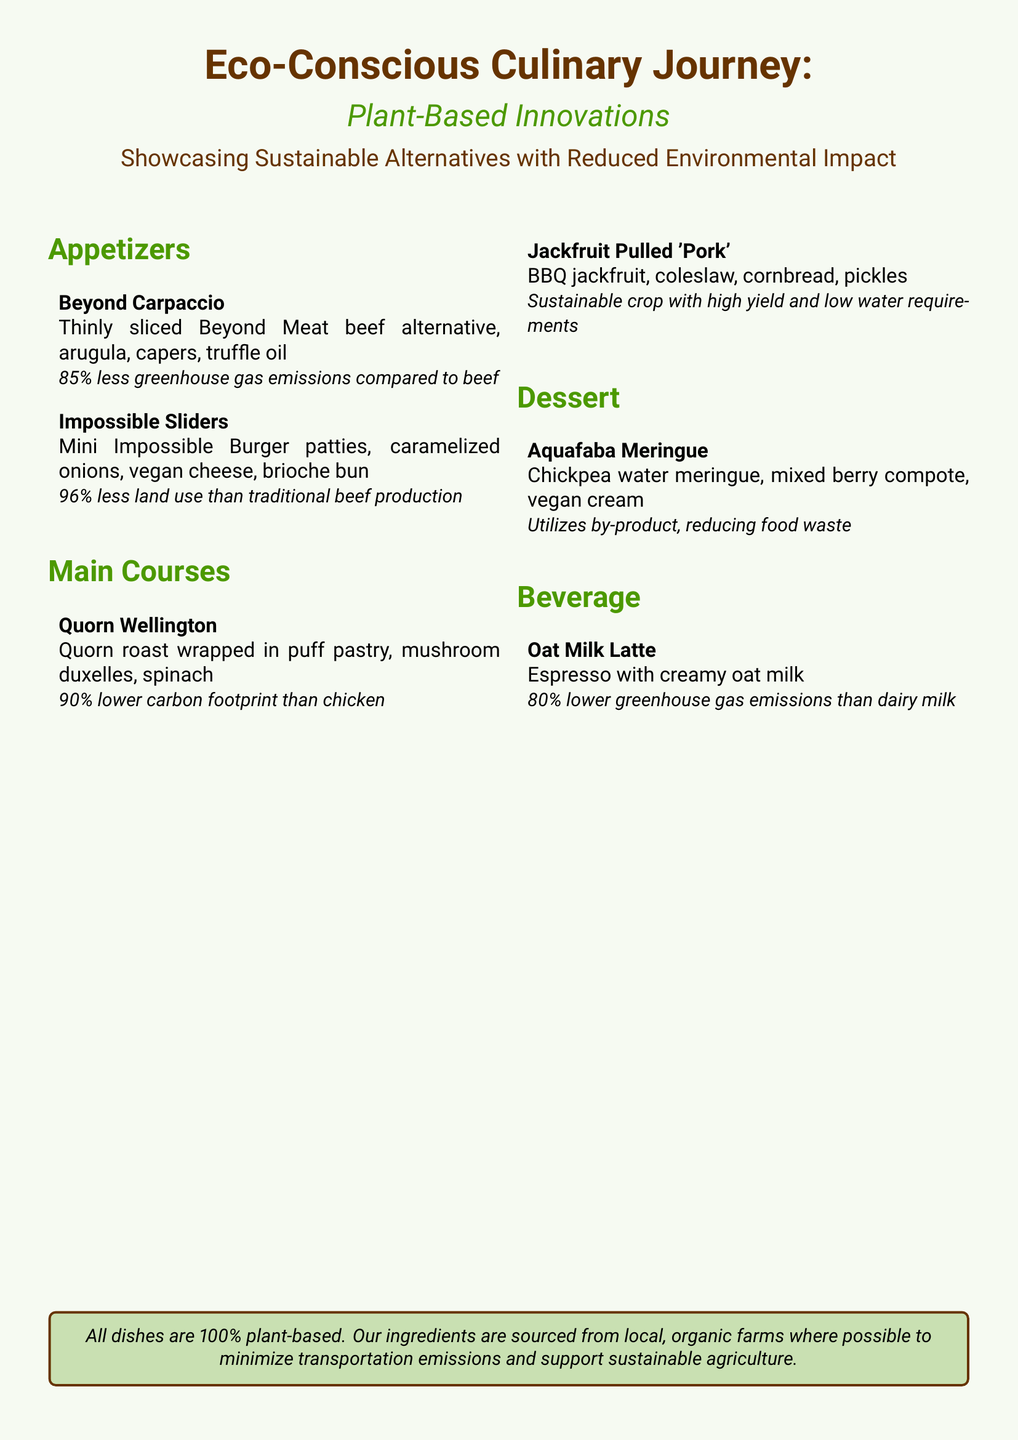What is the title of the menu? The title is prominently displayed at the top of the document, showcasing the theme of the menu.
Answer: Eco-Conscious Culinary Journey How many appetizers are listed? The appetizers section contains a list of dishes, specifically outlining each item.
Answer: 2 What is the environmental impact of Beyond Carpaccio? The menu provides specific data on the environmental benefits of each dish, focusing on emissions.
Answer: 85% less greenhouse gas emissions compared to beef What is the primary ingredient in Jackfruit Pulled 'Pork'? The description of this main course highlights the key ingredient used in the dish.
Answer: Jackfruit What type of drink is featured in the beverage section? This question pertains to the offerings in the beverage section, identifying a specific drink.
Answer: Oat Milk Latte Which dessert utilizes a by-product? The menu describes one dessert that repurposes an ingredient typically discarded, highlighting sustainability.
Answer: Aquafaba Meringue What is the carbon footprint reduction of Quorn Wellington compared to chicken? The menu specifies the percentage reduction in carbon footprint for this dish.
Answer: 90% lower carbon footprint What is the environmental impact of Impossible Sliders in terms of land use? This question aims to retrieve information regarding the land use efficiency of this dish.
Answer: 96% less land use than traditional beef production What type of cuisine does this menu represent? The thematic focus of the dishes collectively points towards a particular culinary style.
Answer: Plant-based 